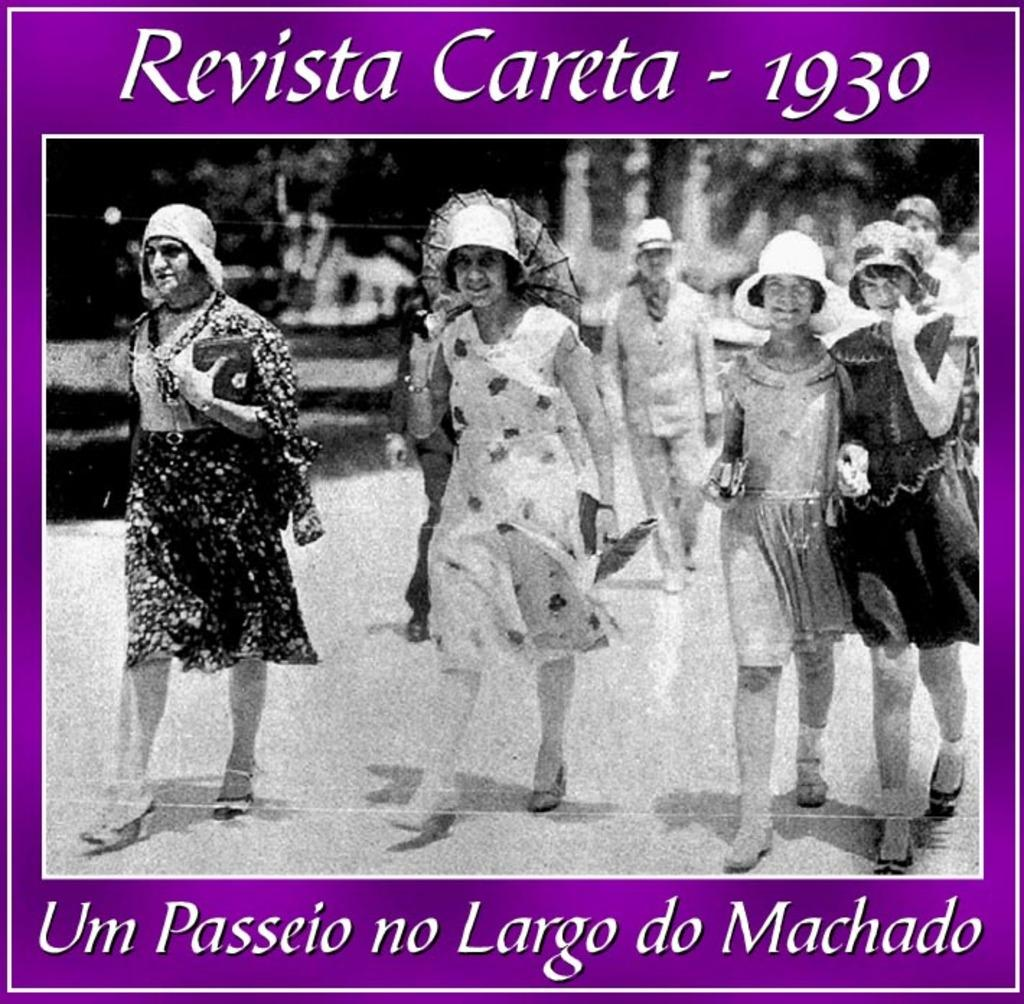What is the main object in the image? There is a poster in the image. What can be seen on the poster? There are people depicted on the poster, and there is text present on the poster. Where is the grass located in the image? There is no grass present in the image; it only features a poster with people and text. 